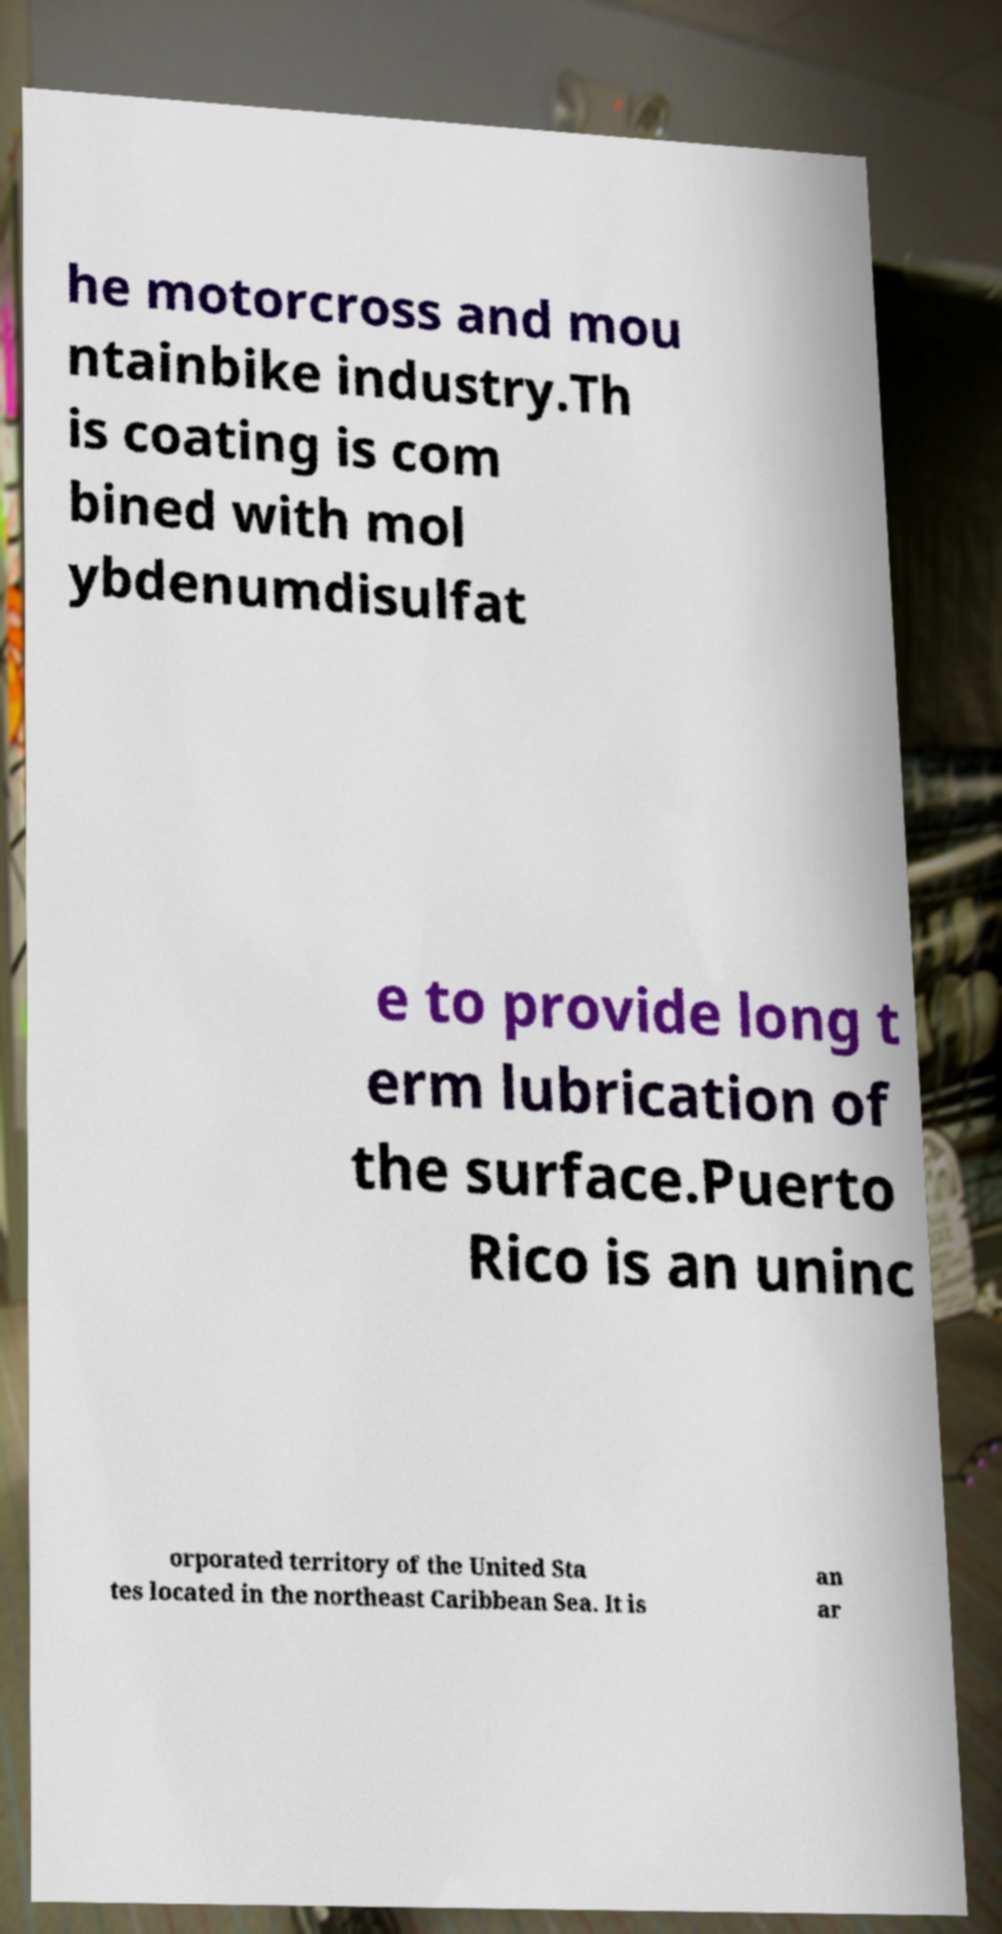Please identify and transcribe the text found in this image. he motorcross and mou ntainbike industry.Th is coating is com bined with mol ybdenumdisulfat e to provide long t erm lubrication of the surface.Puerto Rico is an uninc orporated territory of the United Sta tes located in the northeast Caribbean Sea. It is an ar 